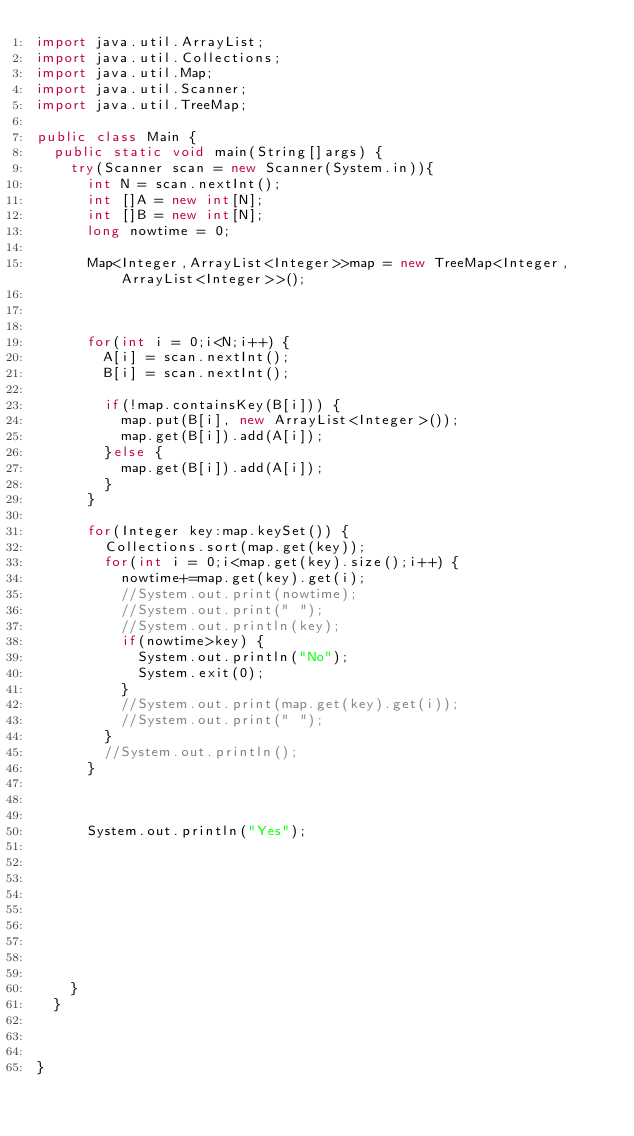Convert code to text. <code><loc_0><loc_0><loc_500><loc_500><_Java_>import java.util.ArrayList;
import java.util.Collections;
import java.util.Map;
import java.util.Scanner;
import java.util.TreeMap;

public class Main {
	public static void main(String[]args) {
		try(Scanner scan = new Scanner(System.in)){
			int N = scan.nextInt();
			int []A = new int[N];
			int []B = new int[N];
			long nowtime = 0;
			
			Map<Integer,ArrayList<Integer>>map = new TreeMap<Integer,ArrayList<Integer>>();
			
			
			
			for(int i = 0;i<N;i++) {
				A[i] = scan.nextInt();
				B[i] = scan.nextInt();
				
				if(!map.containsKey(B[i])) {
					map.put(B[i], new ArrayList<Integer>());
					map.get(B[i]).add(A[i]);
				}else {
					map.get(B[i]).add(A[i]);
				}
			}
			
			for(Integer key:map.keySet()) {
				Collections.sort(map.get(key));
				for(int i = 0;i<map.get(key).size();i++) {
					nowtime+=map.get(key).get(i);
					//System.out.print(nowtime);
					//System.out.print(" ");
					//System.out.println(key);
					if(nowtime>key) {
						System.out.println("No");
						System.exit(0);
					}
					//System.out.print(map.get(key).get(i));
					//System.out.print(" ");
				}
				//System.out.println();
			}
			
			
			
			System.out.println("Yes");
			
			
			
			
			
			
			
			
			
		}
	}
	
	 
	
}
</code> 